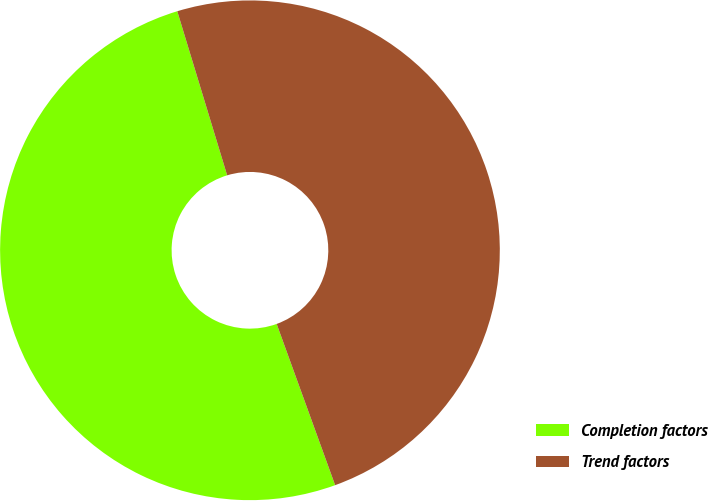<chart> <loc_0><loc_0><loc_500><loc_500><pie_chart><fcel>Completion factors<fcel>Trend factors<nl><fcel>50.84%<fcel>49.16%<nl></chart> 